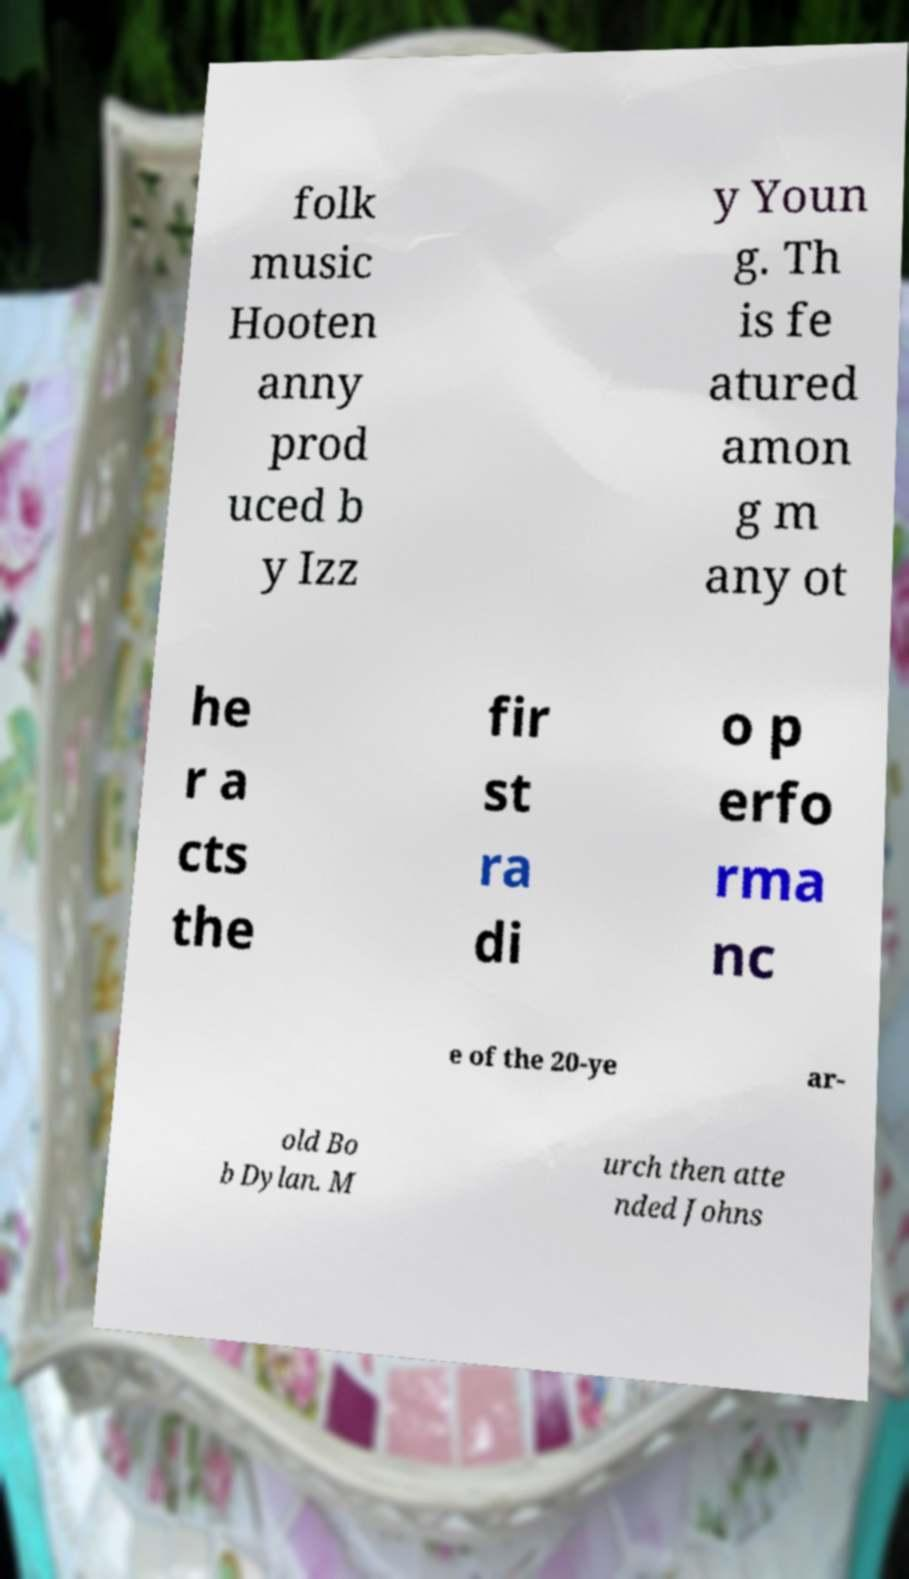Please identify and transcribe the text found in this image. folk music Hooten anny prod uced b y Izz y Youn g. Th is fe atured amon g m any ot he r a cts the fir st ra di o p erfo rma nc e of the 20-ye ar- old Bo b Dylan. M urch then atte nded Johns 